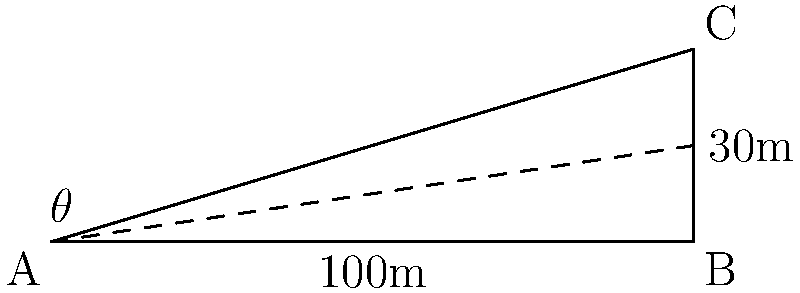As a sniper, you're positioned on a rooftop (point A) and need to take a shot at a target (point C) on another building. The distance between the buildings is 100 meters, and the target is 30 meters above your position. Calculate the angle of elevation ($\theta$) required for the shot. To solve this problem, we'll use trigonometry, specifically the tangent function.

1. Identify the right triangle:
   - The adjacent side is the distance between buildings (100 m)
   - The opposite side is the height difference (30 m)
   - We need to find the angle $\theta$

2. Recall the tangent function:
   $\tan(\theta) = \frac{\text{opposite}}{\text{adjacent}}$

3. Substitute the values:
   $\tan(\theta) = \frac{30}{100} = 0.3$

4. To find $\theta$, we need to use the inverse tangent (arctan or $\tan^{-1}$):
   $\theta = \tan^{-1}(0.3)$

5. Calculate the result:
   $\theta \approx 16.70^\circ$

Therefore, the angle of elevation required for the shot is approximately 16.70 degrees.
Answer: $16.70^\circ$ 